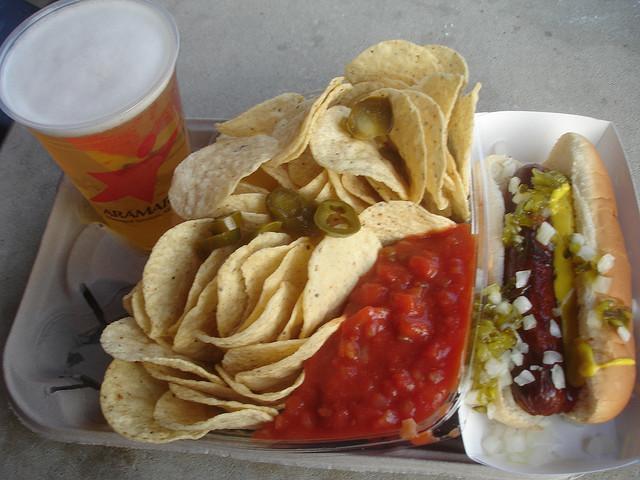What kind of chips are those?
Concise answer only. Tortilla. What type of beverage is on the tray?
Give a very brief answer. Beer. What do you call this type of packaging for a lunch?
Write a very short answer. To go. How many hot dogs are in the photo?
Short answer required. 1. Are there fish in the picture?
Answer briefly. No. What letters are on the glass?
Write a very short answer. Aramark. 